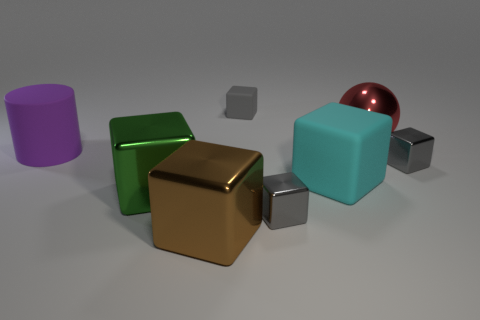Subtract all big brown blocks. How many blocks are left? 5 Subtract all gray cylinders. How many gray cubes are left? 3 Add 2 large brown objects. How many objects exist? 10 Subtract all green cubes. How many cubes are left? 5 Subtract all blocks. How many objects are left? 2 Subtract 4 blocks. How many blocks are left? 2 Subtract 1 purple cylinders. How many objects are left? 7 Subtract all red blocks. Subtract all red balls. How many blocks are left? 6 Subtract all small rubber blocks. Subtract all big purple rubber cylinders. How many objects are left? 6 Add 4 large green metal blocks. How many large green metal blocks are left? 5 